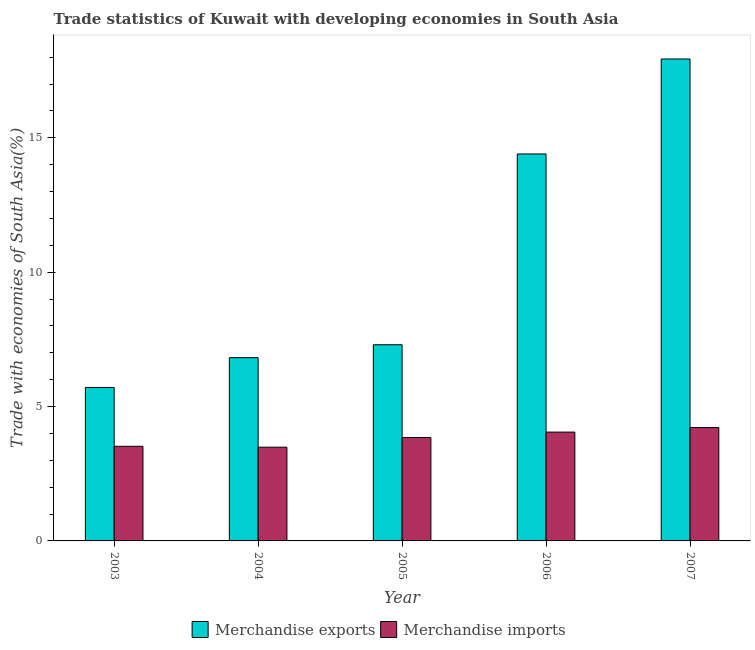How many different coloured bars are there?
Keep it short and to the point. 2. How many bars are there on the 2nd tick from the left?
Keep it short and to the point. 2. How many bars are there on the 5th tick from the right?
Make the answer very short. 2. In how many cases, is the number of bars for a given year not equal to the number of legend labels?
Make the answer very short. 0. What is the merchandise exports in 2004?
Your answer should be compact. 6.82. Across all years, what is the maximum merchandise exports?
Your response must be concise. 17.93. Across all years, what is the minimum merchandise exports?
Give a very brief answer. 5.71. What is the total merchandise exports in the graph?
Your answer should be compact. 52.16. What is the difference between the merchandise exports in 2003 and that in 2005?
Give a very brief answer. -1.59. What is the difference between the merchandise exports in 2005 and the merchandise imports in 2004?
Offer a terse response. 0.48. What is the average merchandise exports per year?
Offer a very short reply. 10.43. In the year 2003, what is the difference between the merchandise exports and merchandise imports?
Your answer should be compact. 0. What is the ratio of the merchandise imports in 2004 to that in 2007?
Offer a very short reply. 0.83. Is the merchandise imports in 2005 less than that in 2007?
Make the answer very short. Yes. What is the difference between the highest and the second highest merchandise imports?
Your answer should be compact. 0.17. What is the difference between the highest and the lowest merchandise imports?
Offer a very short reply. 0.73. What does the 1st bar from the right in 2005 represents?
Offer a very short reply. Merchandise imports. Does the graph contain any zero values?
Make the answer very short. No. Where does the legend appear in the graph?
Make the answer very short. Bottom center. What is the title of the graph?
Offer a terse response. Trade statistics of Kuwait with developing economies in South Asia. What is the label or title of the Y-axis?
Make the answer very short. Trade with economies of South Asia(%). What is the Trade with economies of South Asia(%) in Merchandise exports in 2003?
Your answer should be very brief. 5.71. What is the Trade with economies of South Asia(%) of Merchandise imports in 2003?
Make the answer very short. 3.52. What is the Trade with economies of South Asia(%) of Merchandise exports in 2004?
Make the answer very short. 6.82. What is the Trade with economies of South Asia(%) in Merchandise imports in 2004?
Keep it short and to the point. 3.49. What is the Trade with economies of South Asia(%) of Merchandise exports in 2005?
Ensure brevity in your answer.  7.3. What is the Trade with economies of South Asia(%) in Merchandise imports in 2005?
Keep it short and to the point. 3.85. What is the Trade with economies of South Asia(%) of Merchandise exports in 2006?
Keep it short and to the point. 14.4. What is the Trade with economies of South Asia(%) of Merchandise imports in 2006?
Offer a terse response. 4.05. What is the Trade with economies of South Asia(%) in Merchandise exports in 2007?
Provide a short and direct response. 17.93. What is the Trade with economies of South Asia(%) of Merchandise imports in 2007?
Give a very brief answer. 4.22. Across all years, what is the maximum Trade with economies of South Asia(%) of Merchandise exports?
Keep it short and to the point. 17.93. Across all years, what is the maximum Trade with economies of South Asia(%) in Merchandise imports?
Provide a short and direct response. 4.22. Across all years, what is the minimum Trade with economies of South Asia(%) in Merchandise exports?
Your response must be concise. 5.71. Across all years, what is the minimum Trade with economies of South Asia(%) of Merchandise imports?
Ensure brevity in your answer.  3.49. What is the total Trade with economies of South Asia(%) in Merchandise exports in the graph?
Give a very brief answer. 52.16. What is the total Trade with economies of South Asia(%) of Merchandise imports in the graph?
Give a very brief answer. 19.12. What is the difference between the Trade with economies of South Asia(%) in Merchandise exports in 2003 and that in 2004?
Your answer should be very brief. -1.11. What is the difference between the Trade with economies of South Asia(%) in Merchandise imports in 2003 and that in 2004?
Offer a very short reply. 0.03. What is the difference between the Trade with economies of South Asia(%) of Merchandise exports in 2003 and that in 2005?
Make the answer very short. -1.59. What is the difference between the Trade with economies of South Asia(%) in Merchandise imports in 2003 and that in 2005?
Offer a very short reply. -0.33. What is the difference between the Trade with economies of South Asia(%) of Merchandise exports in 2003 and that in 2006?
Offer a terse response. -8.69. What is the difference between the Trade with economies of South Asia(%) of Merchandise imports in 2003 and that in 2006?
Keep it short and to the point. -0.53. What is the difference between the Trade with economies of South Asia(%) in Merchandise exports in 2003 and that in 2007?
Ensure brevity in your answer.  -12.22. What is the difference between the Trade with economies of South Asia(%) of Merchandise imports in 2003 and that in 2007?
Make the answer very short. -0.7. What is the difference between the Trade with economies of South Asia(%) in Merchandise exports in 2004 and that in 2005?
Your answer should be very brief. -0.48. What is the difference between the Trade with economies of South Asia(%) of Merchandise imports in 2004 and that in 2005?
Offer a terse response. -0.36. What is the difference between the Trade with economies of South Asia(%) of Merchandise exports in 2004 and that in 2006?
Your answer should be compact. -7.58. What is the difference between the Trade with economies of South Asia(%) in Merchandise imports in 2004 and that in 2006?
Your answer should be compact. -0.56. What is the difference between the Trade with economies of South Asia(%) in Merchandise exports in 2004 and that in 2007?
Make the answer very short. -11.11. What is the difference between the Trade with economies of South Asia(%) in Merchandise imports in 2004 and that in 2007?
Keep it short and to the point. -0.73. What is the difference between the Trade with economies of South Asia(%) of Merchandise exports in 2005 and that in 2006?
Keep it short and to the point. -7.1. What is the difference between the Trade with economies of South Asia(%) in Merchandise imports in 2005 and that in 2006?
Your answer should be compact. -0.2. What is the difference between the Trade with economies of South Asia(%) of Merchandise exports in 2005 and that in 2007?
Offer a very short reply. -10.63. What is the difference between the Trade with economies of South Asia(%) in Merchandise imports in 2005 and that in 2007?
Provide a short and direct response. -0.37. What is the difference between the Trade with economies of South Asia(%) in Merchandise exports in 2006 and that in 2007?
Offer a terse response. -3.53. What is the difference between the Trade with economies of South Asia(%) of Merchandise imports in 2006 and that in 2007?
Offer a very short reply. -0.17. What is the difference between the Trade with economies of South Asia(%) in Merchandise exports in 2003 and the Trade with economies of South Asia(%) in Merchandise imports in 2004?
Make the answer very short. 2.22. What is the difference between the Trade with economies of South Asia(%) of Merchandise exports in 2003 and the Trade with economies of South Asia(%) of Merchandise imports in 2005?
Ensure brevity in your answer.  1.86. What is the difference between the Trade with economies of South Asia(%) in Merchandise exports in 2003 and the Trade with economies of South Asia(%) in Merchandise imports in 2006?
Give a very brief answer. 1.66. What is the difference between the Trade with economies of South Asia(%) of Merchandise exports in 2003 and the Trade with economies of South Asia(%) of Merchandise imports in 2007?
Your answer should be compact. 1.49. What is the difference between the Trade with economies of South Asia(%) of Merchandise exports in 2004 and the Trade with economies of South Asia(%) of Merchandise imports in 2005?
Offer a very short reply. 2.97. What is the difference between the Trade with economies of South Asia(%) in Merchandise exports in 2004 and the Trade with economies of South Asia(%) in Merchandise imports in 2006?
Your response must be concise. 2.77. What is the difference between the Trade with economies of South Asia(%) in Merchandise exports in 2004 and the Trade with economies of South Asia(%) in Merchandise imports in 2007?
Give a very brief answer. 2.6. What is the difference between the Trade with economies of South Asia(%) in Merchandise exports in 2005 and the Trade with economies of South Asia(%) in Merchandise imports in 2006?
Offer a very short reply. 3.25. What is the difference between the Trade with economies of South Asia(%) of Merchandise exports in 2005 and the Trade with economies of South Asia(%) of Merchandise imports in 2007?
Provide a short and direct response. 3.08. What is the difference between the Trade with economies of South Asia(%) of Merchandise exports in 2006 and the Trade with economies of South Asia(%) of Merchandise imports in 2007?
Give a very brief answer. 10.18. What is the average Trade with economies of South Asia(%) in Merchandise exports per year?
Provide a succinct answer. 10.43. What is the average Trade with economies of South Asia(%) of Merchandise imports per year?
Keep it short and to the point. 3.82. In the year 2003, what is the difference between the Trade with economies of South Asia(%) in Merchandise exports and Trade with economies of South Asia(%) in Merchandise imports?
Your answer should be very brief. 2.19. In the year 2004, what is the difference between the Trade with economies of South Asia(%) in Merchandise exports and Trade with economies of South Asia(%) in Merchandise imports?
Offer a terse response. 3.33. In the year 2005, what is the difference between the Trade with economies of South Asia(%) in Merchandise exports and Trade with economies of South Asia(%) in Merchandise imports?
Make the answer very short. 3.45. In the year 2006, what is the difference between the Trade with economies of South Asia(%) of Merchandise exports and Trade with economies of South Asia(%) of Merchandise imports?
Provide a short and direct response. 10.35. In the year 2007, what is the difference between the Trade with economies of South Asia(%) in Merchandise exports and Trade with economies of South Asia(%) in Merchandise imports?
Offer a terse response. 13.71. What is the ratio of the Trade with economies of South Asia(%) of Merchandise exports in 2003 to that in 2004?
Your answer should be compact. 0.84. What is the ratio of the Trade with economies of South Asia(%) in Merchandise imports in 2003 to that in 2004?
Keep it short and to the point. 1.01. What is the ratio of the Trade with economies of South Asia(%) in Merchandise exports in 2003 to that in 2005?
Offer a very short reply. 0.78. What is the ratio of the Trade with economies of South Asia(%) of Merchandise imports in 2003 to that in 2005?
Your answer should be compact. 0.91. What is the ratio of the Trade with economies of South Asia(%) in Merchandise exports in 2003 to that in 2006?
Make the answer very short. 0.4. What is the ratio of the Trade with economies of South Asia(%) in Merchandise imports in 2003 to that in 2006?
Give a very brief answer. 0.87. What is the ratio of the Trade with economies of South Asia(%) of Merchandise exports in 2003 to that in 2007?
Ensure brevity in your answer.  0.32. What is the ratio of the Trade with economies of South Asia(%) in Merchandise imports in 2003 to that in 2007?
Ensure brevity in your answer.  0.83. What is the ratio of the Trade with economies of South Asia(%) in Merchandise exports in 2004 to that in 2005?
Your answer should be very brief. 0.93. What is the ratio of the Trade with economies of South Asia(%) in Merchandise imports in 2004 to that in 2005?
Ensure brevity in your answer.  0.91. What is the ratio of the Trade with economies of South Asia(%) of Merchandise exports in 2004 to that in 2006?
Your response must be concise. 0.47. What is the ratio of the Trade with economies of South Asia(%) of Merchandise imports in 2004 to that in 2006?
Your answer should be compact. 0.86. What is the ratio of the Trade with economies of South Asia(%) of Merchandise exports in 2004 to that in 2007?
Provide a succinct answer. 0.38. What is the ratio of the Trade with economies of South Asia(%) of Merchandise imports in 2004 to that in 2007?
Provide a short and direct response. 0.83. What is the ratio of the Trade with economies of South Asia(%) in Merchandise exports in 2005 to that in 2006?
Keep it short and to the point. 0.51. What is the ratio of the Trade with economies of South Asia(%) in Merchandise imports in 2005 to that in 2006?
Make the answer very short. 0.95. What is the ratio of the Trade with economies of South Asia(%) in Merchandise exports in 2005 to that in 2007?
Your answer should be compact. 0.41. What is the ratio of the Trade with economies of South Asia(%) in Merchandise imports in 2005 to that in 2007?
Provide a succinct answer. 0.91. What is the ratio of the Trade with economies of South Asia(%) of Merchandise exports in 2006 to that in 2007?
Make the answer very short. 0.8. What is the ratio of the Trade with economies of South Asia(%) of Merchandise imports in 2006 to that in 2007?
Give a very brief answer. 0.96. What is the difference between the highest and the second highest Trade with economies of South Asia(%) in Merchandise exports?
Your answer should be very brief. 3.53. What is the difference between the highest and the second highest Trade with economies of South Asia(%) in Merchandise imports?
Ensure brevity in your answer.  0.17. What is the difference between the highest and the lowest Trade with economies of South Asia(%) of Merchandise exports?
Your response must be concise. 12.22. What is the difference between the highest and the lowest Trade with economies of South Asia(%) in Merchandise imports?
Provide a succinct answer. 0.73. 